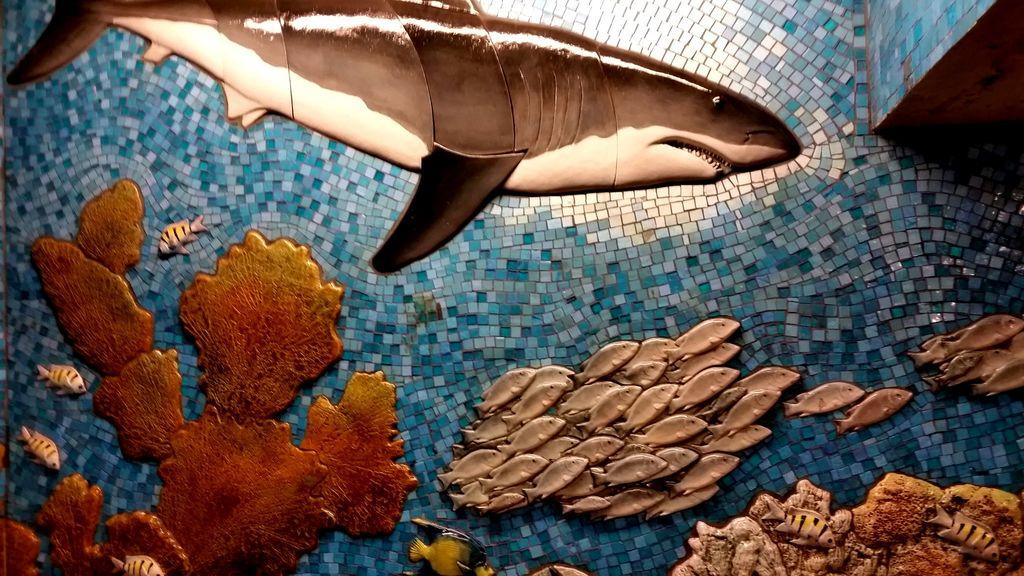What is the subject of the painting in the image? The painting is of an aquarium. What type of marine animal can be seen in the painting? There is a shark in the painting. What other creatures are present in the painting? There are fishes in the painting. What type of vegetation is depicted in the painting? There are underwater plants in the painting. Can you see a volcano erupting in the painting? No, there is no volcano present in the painting; it depicts an aquarium with marine life and underwater plants. 